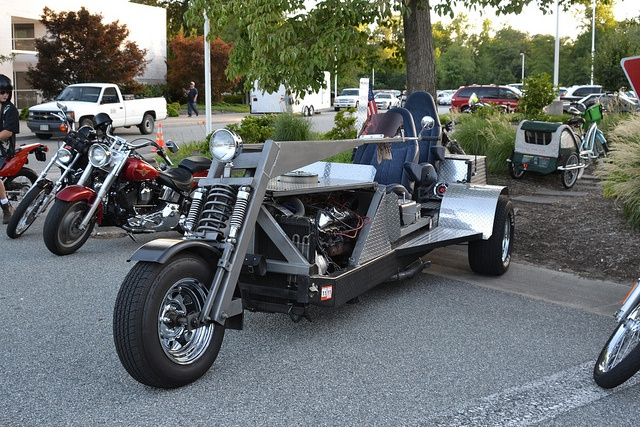Describe the objects in this image and their specific colors. I can see motorcycle in white, black, gray, darkgray, and navy tones, motorcycle in white, black, gray, and darkgray tones, truck in white, black, gray, and darkgray tones, motorcycle in white, black, gray, and darkgray tones, and motorcycle in white, black, gray, lightblue, and darkgray tones in this image. 